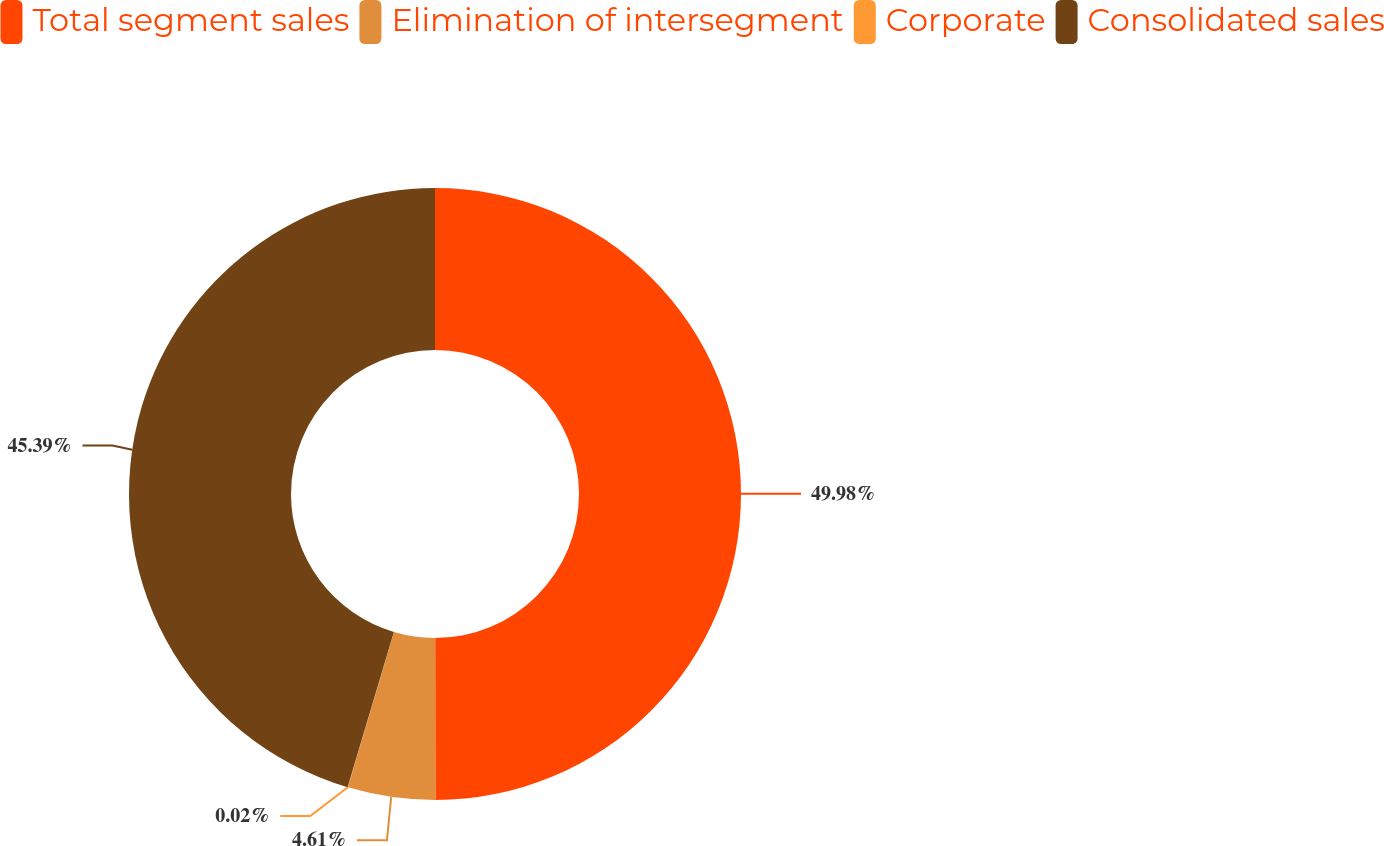Convert chart. <chart><loc_0><loc_0><loc_500><loc_500><pie_chart><fcel>Total segment sales<fcel>Elimination of intersegment<fcel>Corporate<fcel>Consolidated sales<nl><fcel>49.98%<fcel>4.61%<fcel>0.02%<fcel>45.39%<nl></chart> 